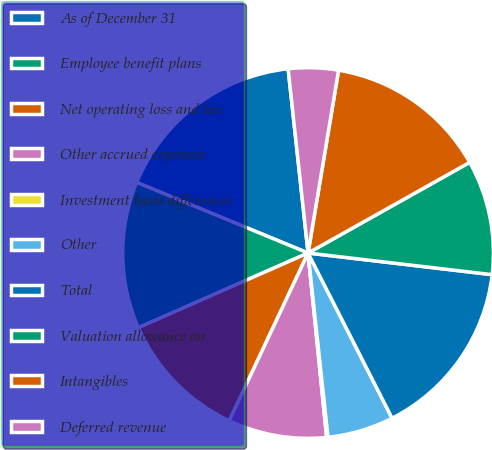Convert chart to OTSL. <chart><loc_0><loc_0><loc_500><loc_500><pie_chart><fcel>As of December 31<fcel>Employee benefit plans<fcel>Net operating loss and tax<fcel>Other accrued expenses<fcel>Investment basis differences<fcel>Other<fcel>Total<fcel>Valuation allowance on<fcel>Intangibles<fcel>Deferred revenue<nl><fcel>17.06%<fcel>12.82%<fcel>11.41%<fcel>8.59%<fcel>0.12%<fcel>5.77%<fcel>15.65%<fcel>10.0%<fcel>14.23%<fcel>4.35%<nl></chart> 